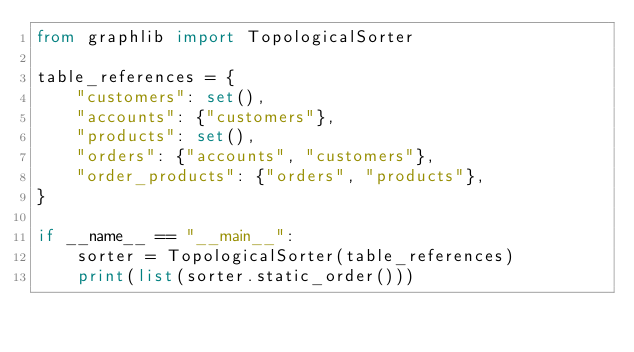Convert code to text. <code><loc_0><loc_0><loc_500><loc_500><_Python_>from graphlib import TopologicalSorter

table_references = {
    "customers": set(),
    "accounts": {"customers"},
    "products": set(),
    "orders": {"accounts", "customers"},
    "order_products": {"orders", "products"},
}

if __name__ == "__main__":
    sorter = TopologicalSorter(table_references)
    print(list(sorter.static_order()))
</code> 